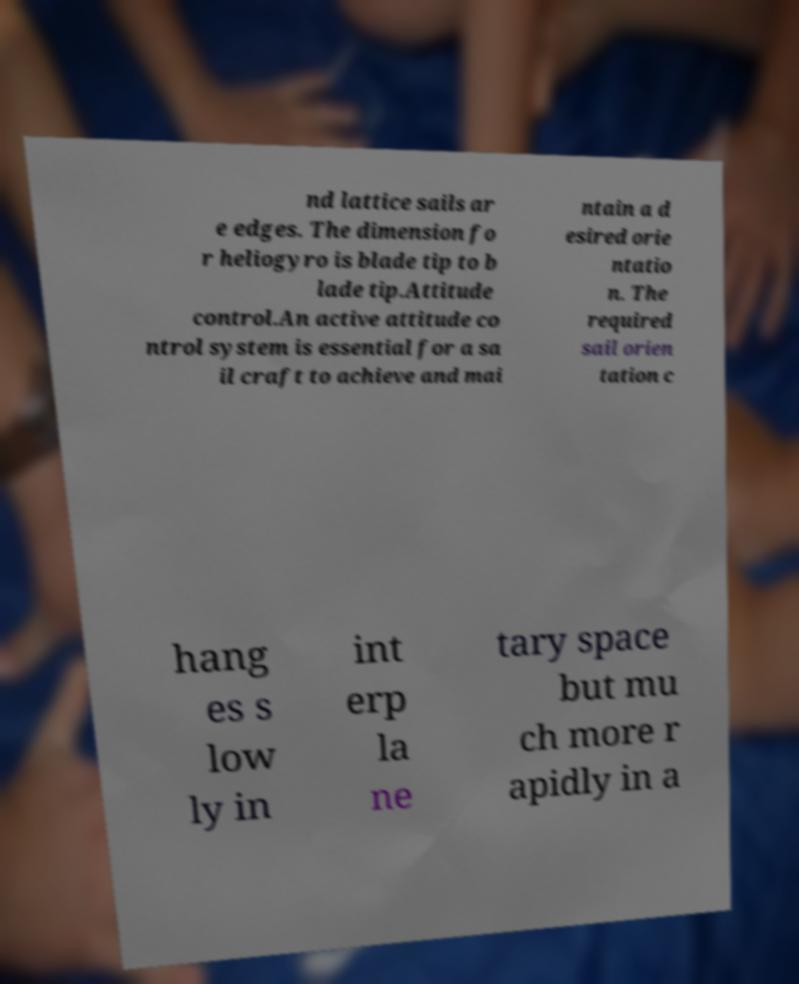Can you accurately transcribe the text from the provided image for me? nd lattice sails ar e edges. The dimension fo r heliogyro is blade tip to b lade tip.Attitude control.An active attitude co ntrol system is essential for a sa il craft to achieve and mai ntain a d esired orie ntatio n. The required sail orien tation c hang es s low ly in int erp la ne tary space but mu ch more r apidly in a 